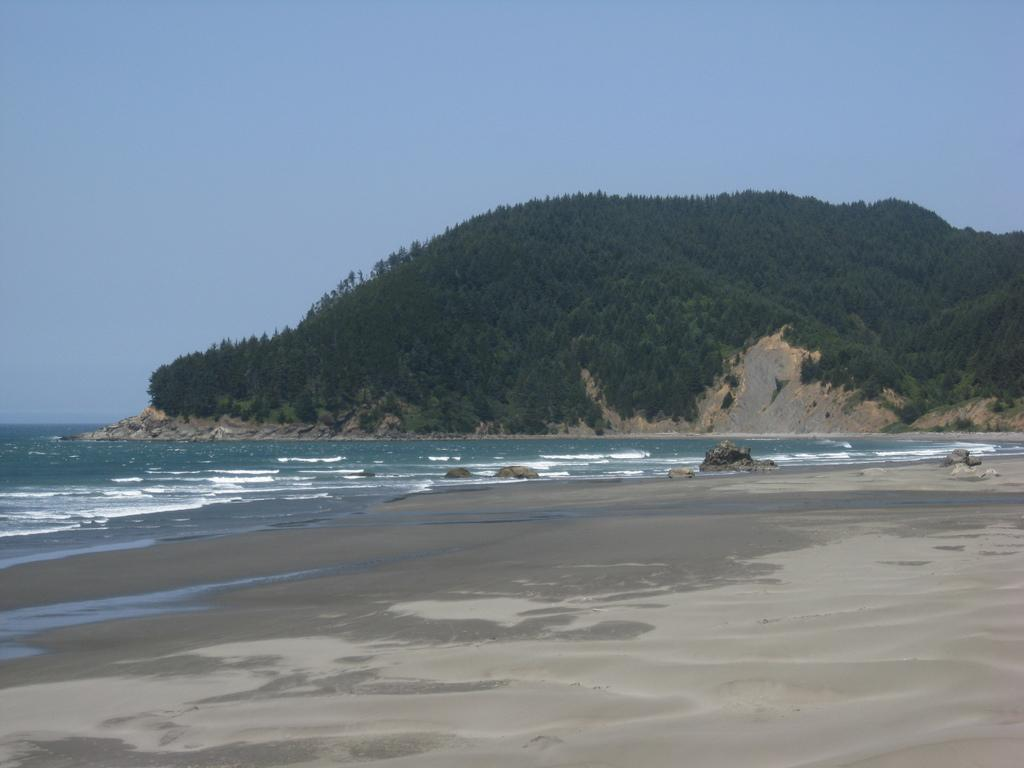What type of rock is present in the image? There is sandstone in the image. What natural element is also present in the image? There is water in the image. What geographical feature can be seen in the image? There is a hill in the image. What is visible in the background of the image? The sky is visible in the image. What type of meat is being cooked on the hill in the image? There is no meat or cooking activity present in the image; it features sandstone, water, a hill, and the sky. What type of lace can be seen draped over the sandstone in the image? There is no lace present in the image; it only features sandstone, water, a hill, and the sky. 